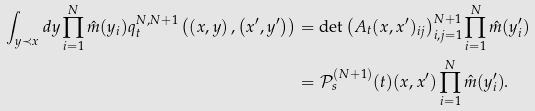<formula> <loc_0><loc_0><loc_500><loc_500>\int _ { y \prec x } d y \prod _ { i = 1 } ^ { N } \hat { m } ( y _ { i } ) q _ { t } ^ { N , N + 1 } \left ( \left ( x , y \right ) , \left ( x ^ { \prime } , y ^ { \prime } \right ) \right ) & = \det \left ( { A } _ { t } ( x , x ^ { \prime } ) _ { i j } \right ) _ { i , j = 1 } ^ { N + 1 } \prod _ { i = 1 } ^ { N } \hat { m } ( y _ { i } ^ { \prime } ) \\ & = \mathcal { P } ^ { ( N + 1 ) } _ { s } ( t ) ( x , x ^ { \prime } ) \prod _ { i = 1 } ^ { N } \hat { m } ( y _ { i } ^ { \prime } ) .</formula> 